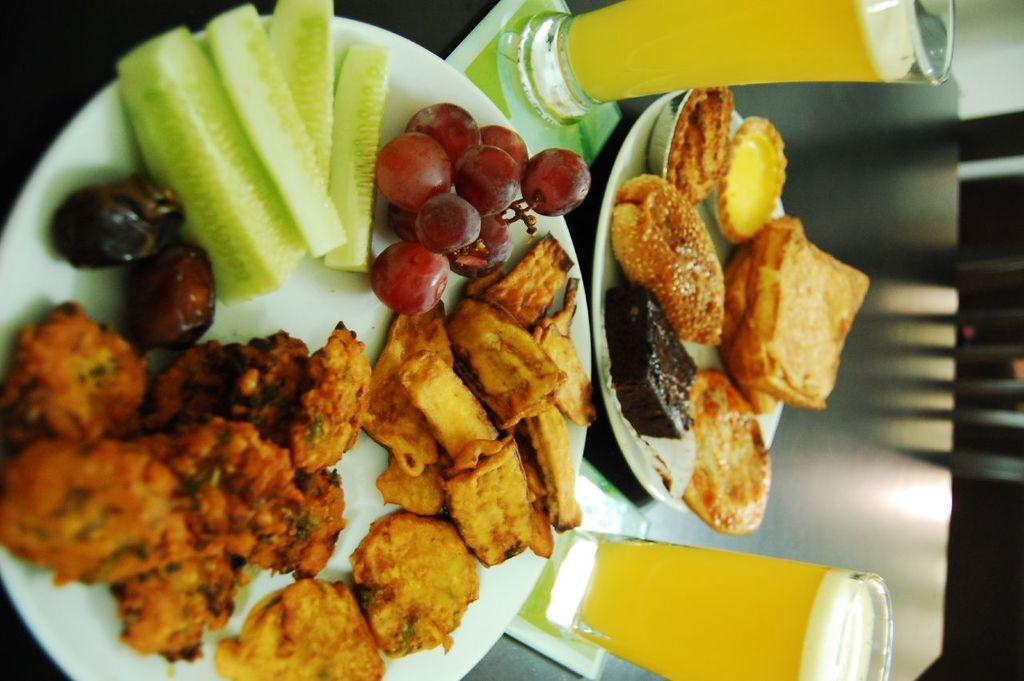What piece of furniture is present in the image? There is a table in the image. What objects are placed on the table? There are plates and glasses on the table. What is on the plates? There are food items on the plates. Can you describe the seating arrangement in the image? There appears to be a chair on the right side of the image. How many balls are visible on the table in the image? There are no balls present on the table in the image. What type of line is drawn across the plates in the image? There is no line drawn across the plates in the image. 